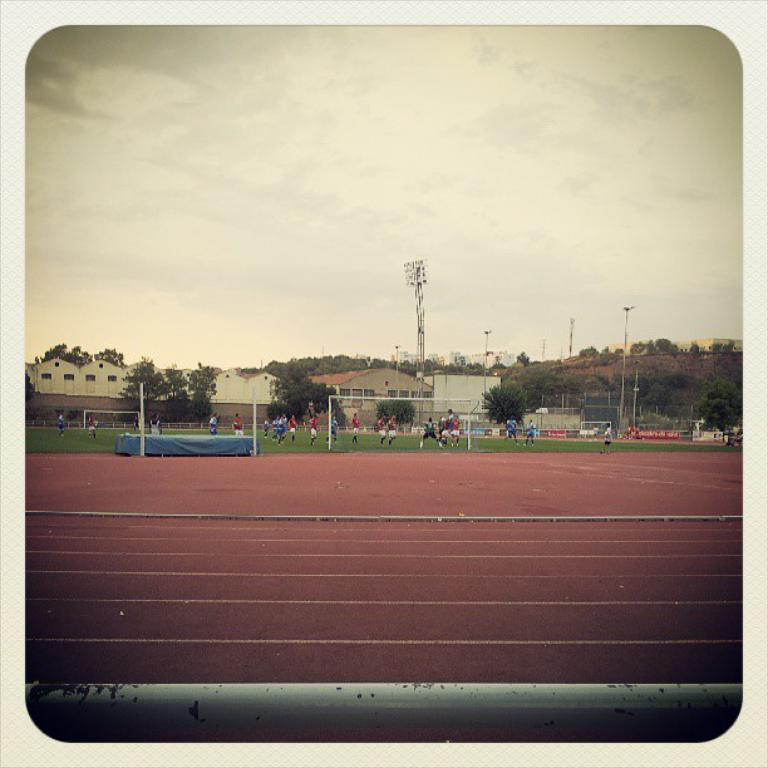What can be observed about the players in the image? The players are wearing different color dresses in the image. What objects are present in the image that are related to the game or activity? There are poles and boards in the image. What type of natural elements can be seen in the image? There are trees in the image. What type of man-made structures are visible in the image? There are buildings in the image. What architectural feature can be seen in the buildings? There are windows in the buildings. What part of the natural environment is visible in the image? The sky is visible in the image. How many lines are visible on the quarter in the image? There is no quarter present in the image, so it is not possible to determine the number of lines on it. 